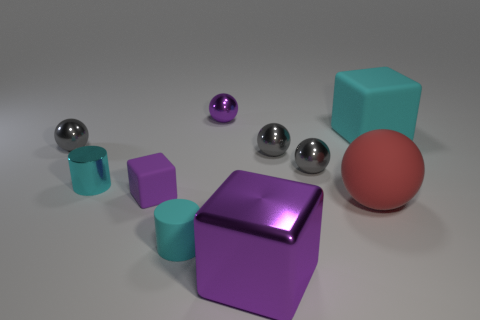Subtract all green cylinders. How many gray spheres are left? 3 Subtract all large red rubber spheres. How many spheres are left? 4 Subtract all red spheres. How many spheres are left? 4 Subtract all yellow spheres. Subtract all brown cylinders. How many spheres are left? 5 Subtract all cylinders. How many objects are left? 8 Subtract 0 green blocks. How many objects are left? 10 Subtract all purple metallic objects. Subtract all tiny blue rubber blocks. How many objects are left? 8 Add 1 cyan matte cubes. How many cyan matte cubes are left? 2 Add 8 tiny yellow shiny spheres. How many tiny yellow shiny spheres exist? 8 